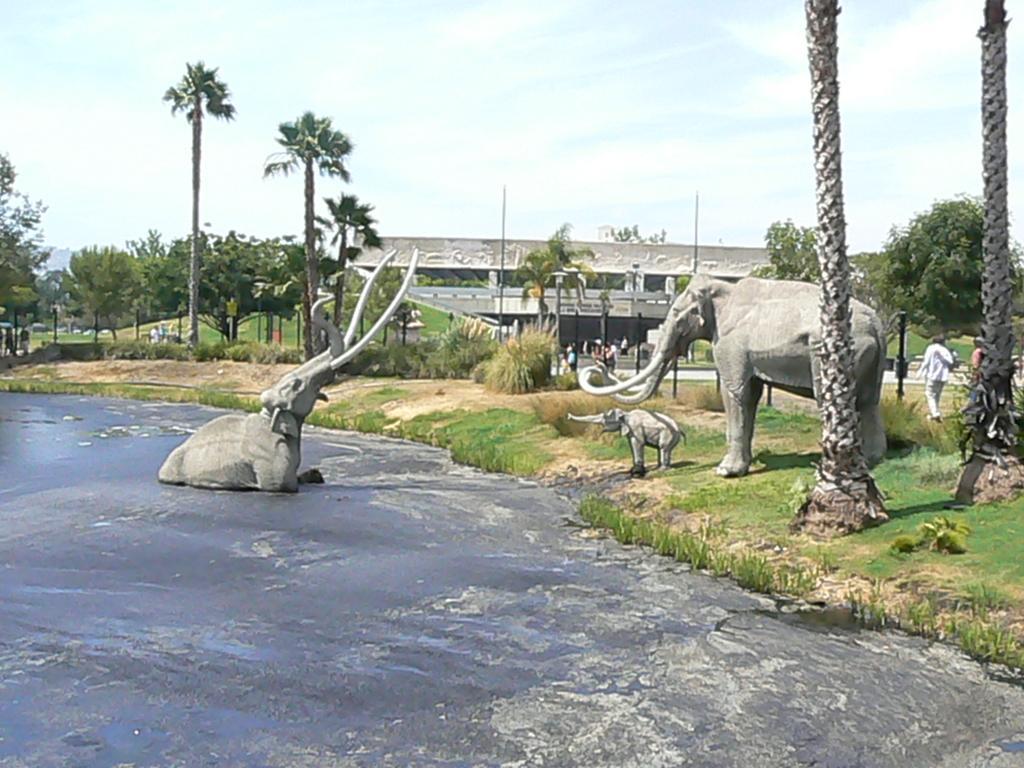In one or two sentences, can you explain what this image depicts? At the bottom of the image there is water. In the middle of the image there are some elephant statues. Behind them there is grass and trees and poles and few people are walking. At the top of the image there are some clouds and sky. 